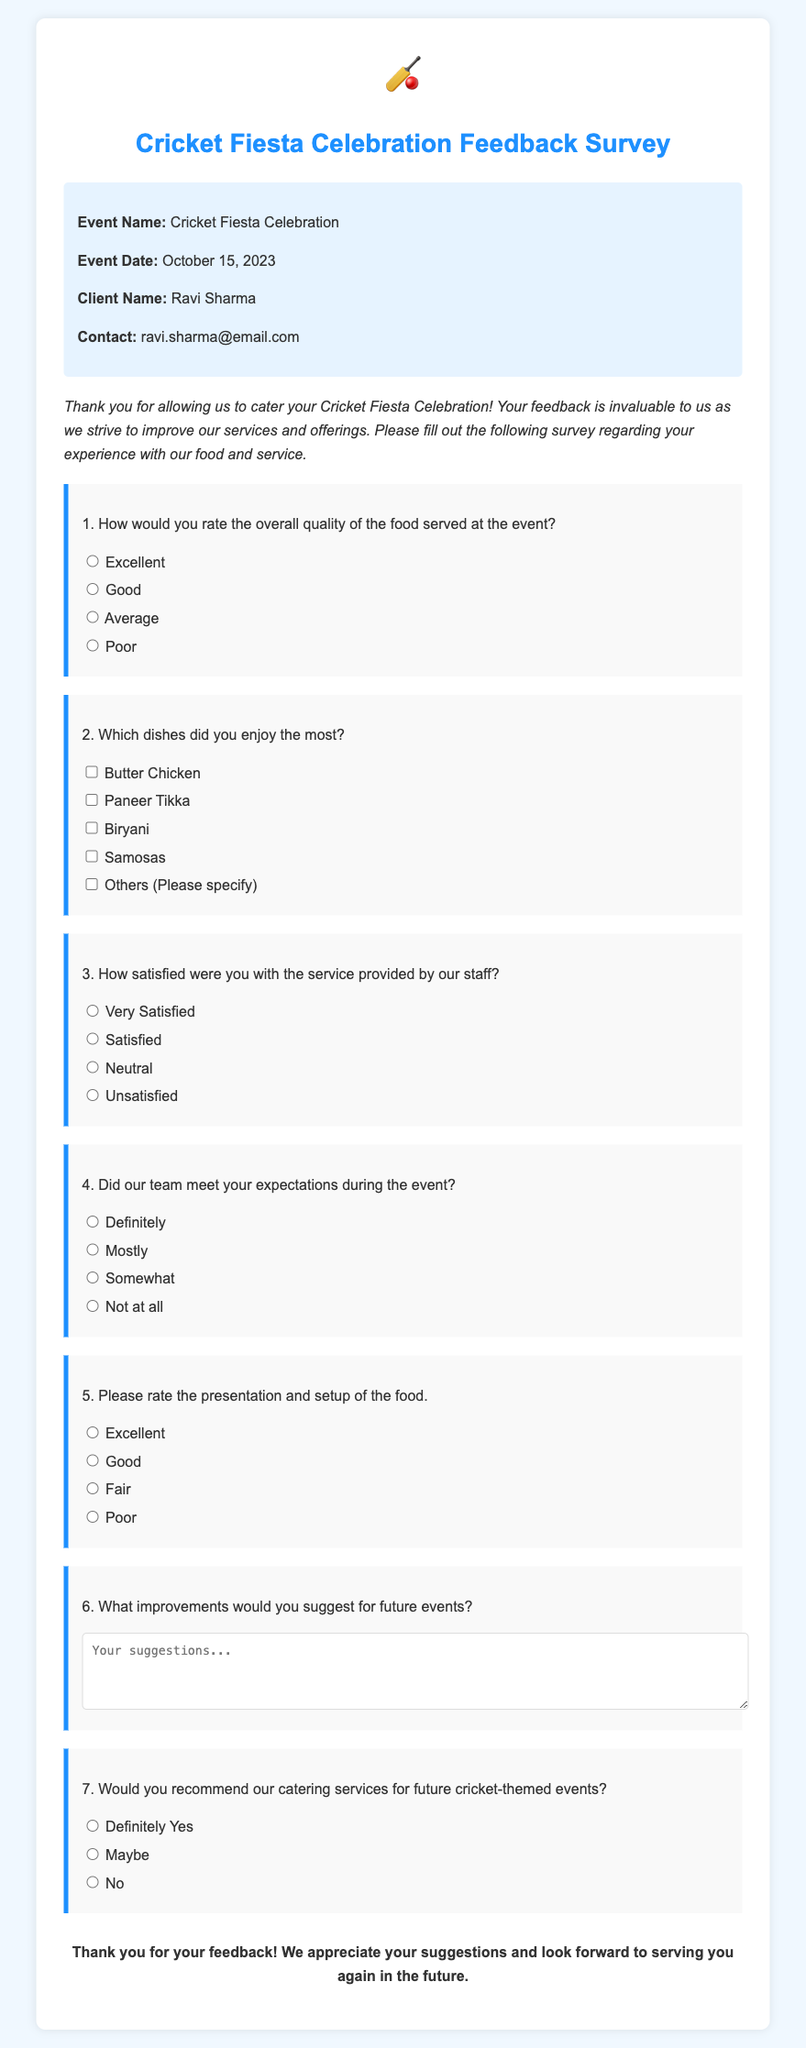What is the title of the document? The title of the document is found in the header section, stating the purpose of the document.
Answer: Cricket Fiesta Celebration Feedback Survey What is the event date? The event date is provided in the event details section, clarifying when the event took place.
Answer: October 15, 2023 Who is the client for this event? The client name is listed in the event details, indicating who organized the event.
Answer: Ravi Sharma What type of dishes were listed for feedback? The document includes a list of dishes that participants could provide feedback on, highlighting the catering offerings.
Answer: Butter Chicken, Paneer Tikka, Biryani, Samosas How many options are given for rating the overall quality of the food? The number of options is presented through multiple choice responses for rating the food quality.
Answer: Four What aspect of the service is specifically queried in the survey? The survey includes a question that directly addresses the satisfaction level of the service provided.
Answer: Service satisfaction Which question assesses the presentation and setup of the food? The survey contains a specific question aimed at evaluating how well the food was presented and arranged.
Answer: Question 5 What closing statement is included in the survey? The closing statement summarizes the purpose of the survey and expresses gratitude for feedback, found at the end of the document.
Answer: Thank you for your feedback! We appreciate your suggestions and look forward to serving you again in the future 